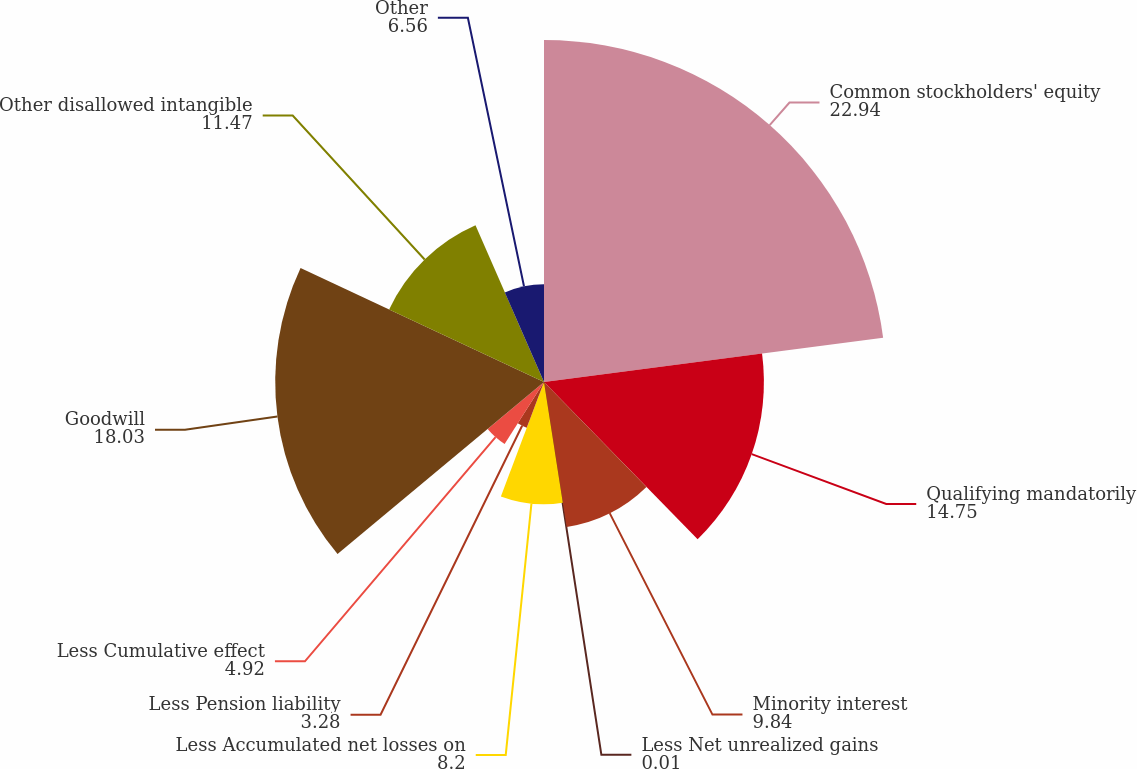Convert chart to OTSL. <chart><loc_0><loc_0><loc_500><loc_500><pie_chart><fcel>Common stockholders' equity<fcel>Qualifying mandatorily<fcel>Minority interest<fcel>Less Net unrealized gains<fcel>Less Accumulated net losses on<fcel>Less Pension liability<fcel>Less Cumulative effect<fcel>Goodwill<fcel>Other disallowed intangible<fcel>Other<nl><fcel>22.94%<fcel>14.75%<fcel>9.84%<fcel>0.01%<fcel>8.2%<fcel>3.28%<fcel>4.92%<fcel>18.03%<fcel>11.47%<fcel>6.56%<nl></chart> 